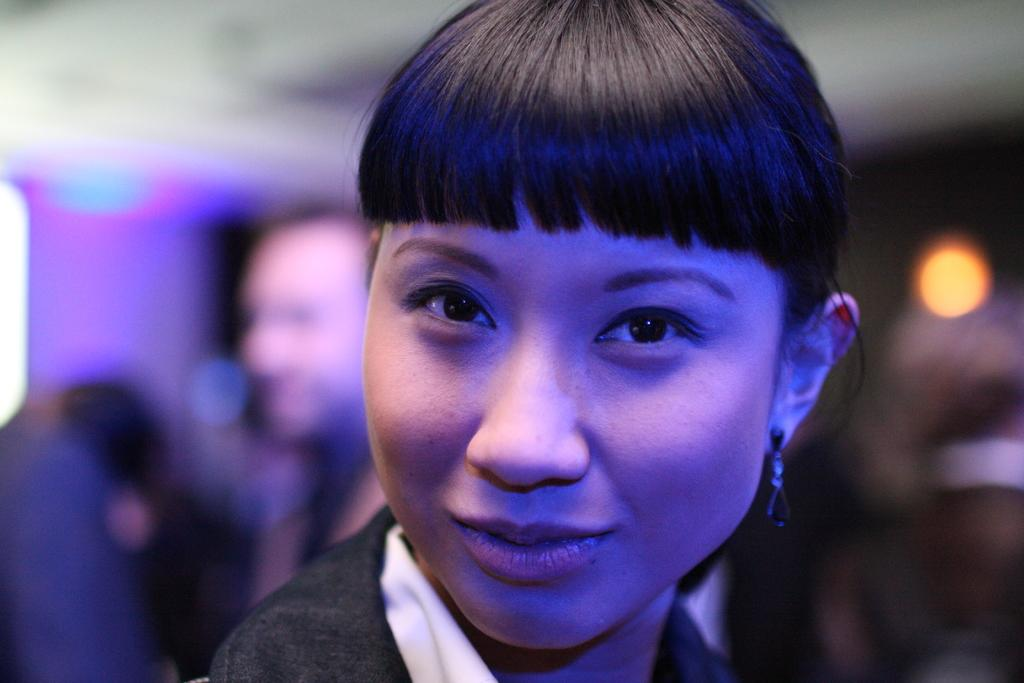What is the main subject of the image? There is a beautiful woman in the image. Can you describe the woman's clothing? The woman is wearing a black top. What type of whistle can be heard in the image? There is no whistle present in the image, and therefore no sound can be heard. 